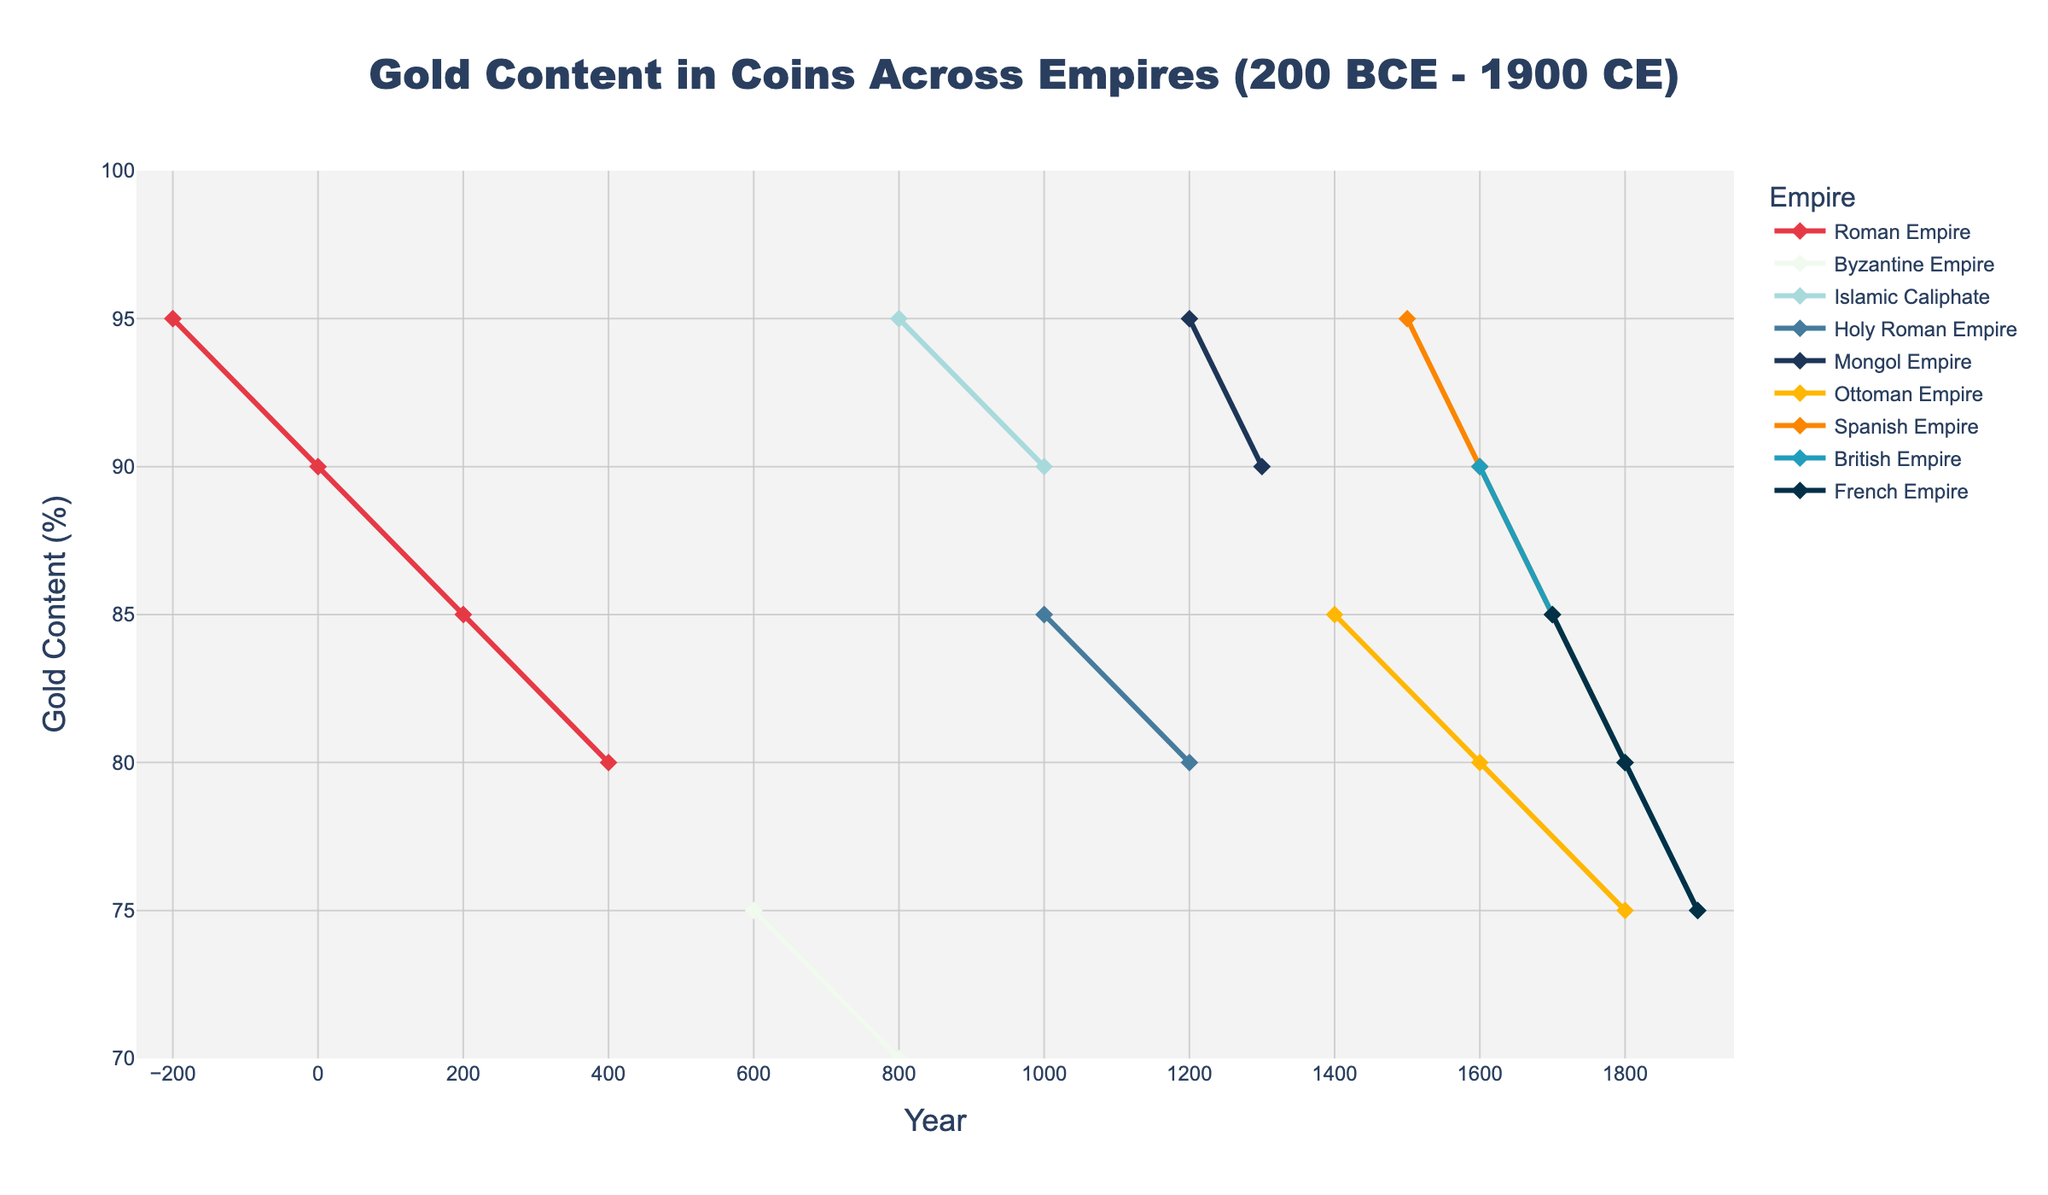What empire had the highest gold content in coins around the year 800? To determine this, examine the data points around the year 800 across different empires. The Islamic Caliphate shows a gold content of 95%, which is the highest.
Answer: Islamic Caliphate Which two empires maintained gold content of 90% or higher for the longest period? Look at the line trends for each empire. The Roman Empire maintained 90% or higher from -200 to 0 (200 years), and the Islamic Caliphate maintained it from 800 to 1000 (200 years).
Answer: Roman Empire and Islamic Caliphate How does the average gold content in coins for the Ottoman Empire compare with that of the British Empire over the period shown? Calculate the average gold content for both empires across the range provided: Ottoman Empire from 1400 (85%), 1600 (80%), 1800 (75%); British Empire from 1600 (90%), 1700 (85%), 1800 (80%), 1900 (75%). The averages are (85+80+75)/3 and (90+85+80+75)/4.
Answer: Ottoman: 80%, British: 82.5% Which empire shows the most significant decline in gold content over time? Compare the differences between the initial and final points for each empire. The Roman Empire drops from 95% to 80%, a 15% decline, while others have varying declines with the British Empire going from 90% to 75%, a 15% decline as well.
Answer: Roman Empire and British Empire In which century did the French Empire show a drop in gold content? Look at the data points for the French Empire. There is a change between 1700 (85%) and 1800 (80%), indicating the 18th century.
Answer: 18th century What is the difference in gold content between the Mongol Empire and the Holy Roman Empire in the year 1200? Find the data points for both empires in 1200. The gold content for the Mongol Empire is 95% and for the Holy Roman Empire is 80%, thus the difference is 95% - 80%.
Answer: 15% Which empires had a gold content in coins of exactly 85% at any point during the timeframe? Check the data to identify empires that had 85% gold content. The Roman Empire in 200 and the Holy Roman Empire in 1000, and the Ottoman Empire in 1400, Spanish Empire in 1700, British Empire in 1700, and French Empire in 1700.
Answer: Roman, Holy Roman, Ottoman, Spanish, British, French What trend do you observe in the gold content of coins in the Spanish Empire from 1500 to 1800? Plot out the gold content values for the Spanish Empire: 1500 (95%), 1600 (90%), 1700 (85%), 1800 (80%). This shows a steady decline.
Answer: Steady decline 